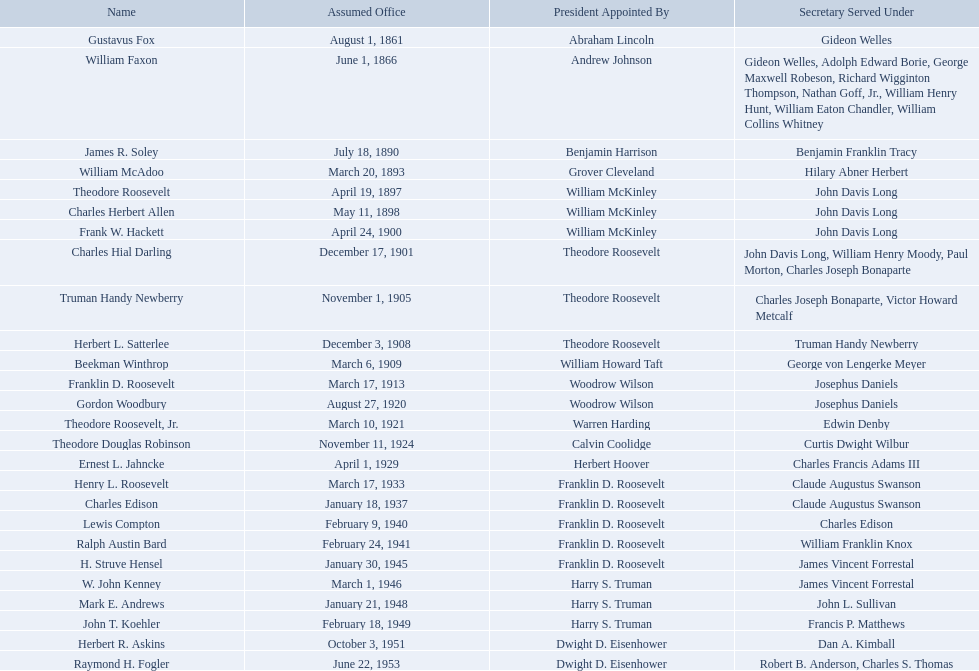Who were all the assistant secretary's of the navy? Gustavus Fox, William Faxon, James R. Soley, William McAdoo, Theodore Roosevelt, Charles Herbert Allen, Frank W. Hackett, Charles Hial Darling, Truman Handy Newberry, Herbert L. Satterlee, Beekman Winthrop, Franklin D. Roosevelt, Gordon Woodbury, Theodore Roosevelt, Jr., Theodore Douglas Robinson, Ernest L. Jahncke, Henry L. Roosevelt, Charles Edison, Lewis Compton, Ralph Austin Bard, H. Struve Hensel, W. John Kenney, Mark E. Andrews, John T. Koehler, Herbert R. Askins, Raymond H. Fogler. What are the various dates they left office in? November 26, 1866, March 3, 1889, March 19, 1893, April 18, 1897, May 10, 1898, April 21, 1900, December 16, 1901, October 30, 1905, November 30, 1908, March 5, 1909, March 16, 1913, August 26, 1920, March 9, 1921, September 30, 1924, March 4, 1929, March 17, 1933, February 22, 1936, January 1, 1940, January 10, 1941, June 24, 1944, February 28, 1946, September 19, 1947, February 15, 1949, October 3, 1951, January 20, 1953, October 4, 1954. Of these dates, which was the date raymond h. fogler left office in? October 4, 1954. Who are all of the assistant secretaries of the navy in the 20th century? Charles Herbert Allen, Frank W. Hackett, Charles Hial Darling, Truman Handy Newberry, Herbert L. Satterlee, Beekman Winthrop, Franklin D. Roosevelt, Gordon Woodbury, Theodore Roosevelt, Jr., Theodore Douglas Robinson, Ernest L. Jahncke, Henry L. Roosevelt, Charles Edison, Lewis Compton, Ralph Austin Bard, H. Struve Hensel, W. John Kenney, Mark E. Andrews, John T. Koehler, Herbert R. Askins, Raymond H. Fogler. What date was assistant secretary of the navy raymond h. fogler appointed? June 22, 1953. What date did assistant secretary of the navy raymond h. fogler leave office? October 4, 1954. 